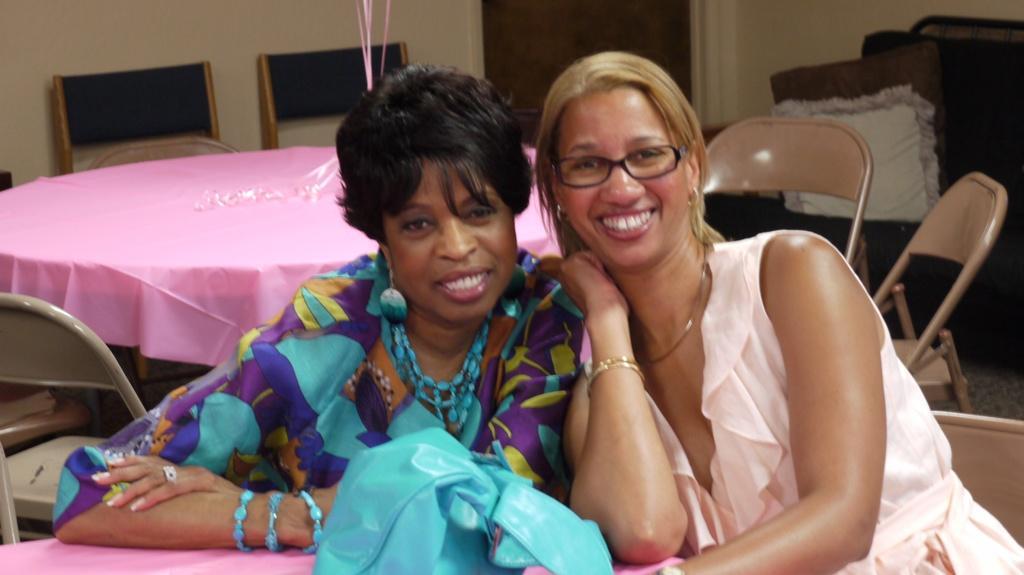How would you summarize this image in a sentence or two? In this picture we can see two woman are smiling where this woman wore spectacle and at back of them we can see table cloth on it, chairs, wall, pillows. 